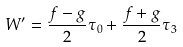<formula> <loc_0><loc_0><loc_500><loc_500>W ^ { \prime } = \frac { f - g } { 2 } \tau _ { 0 } + \frac { f + g } { 2 } \tau _ { 3 }</formula> 